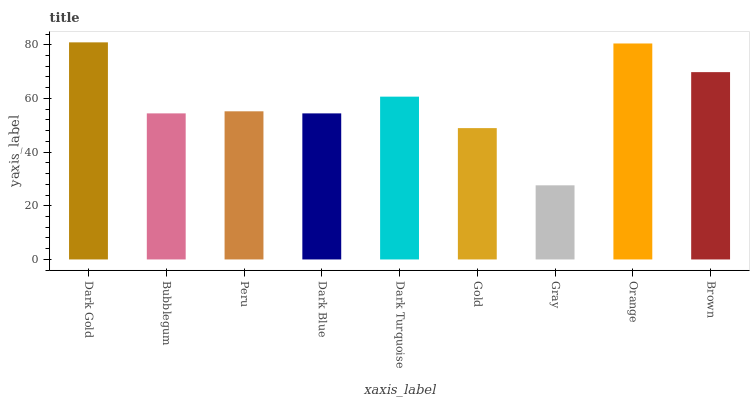Is Gray the minimum?
Answer yes or no. Yes. Is Dark Gold the maximum?
Answer yes or no. Yes. Is Bubblegum the minimum?
Answer yes or no. No. Is Bubblegum the maximum?
Answer yes or no. No. Is Dark Gold greater than Bubblegum?
Answer yes or no. Yes. Is Bubblegum less than Dark Gold?
Answer yes or no. Yes. Is Bubblegum greater than Dark Gold?
Answer yes or no. No. Is Dark Gold less than Bubblegum?
Answer yes or no. No. Is Peru the high median?
Answer yes or no. Yes. Is Peru the low median?
Answer yes or no. Yes. Is Gray the high median?
Answer yes or no. No. Is Bubblegum the low median?
Answer yes or no. No. 